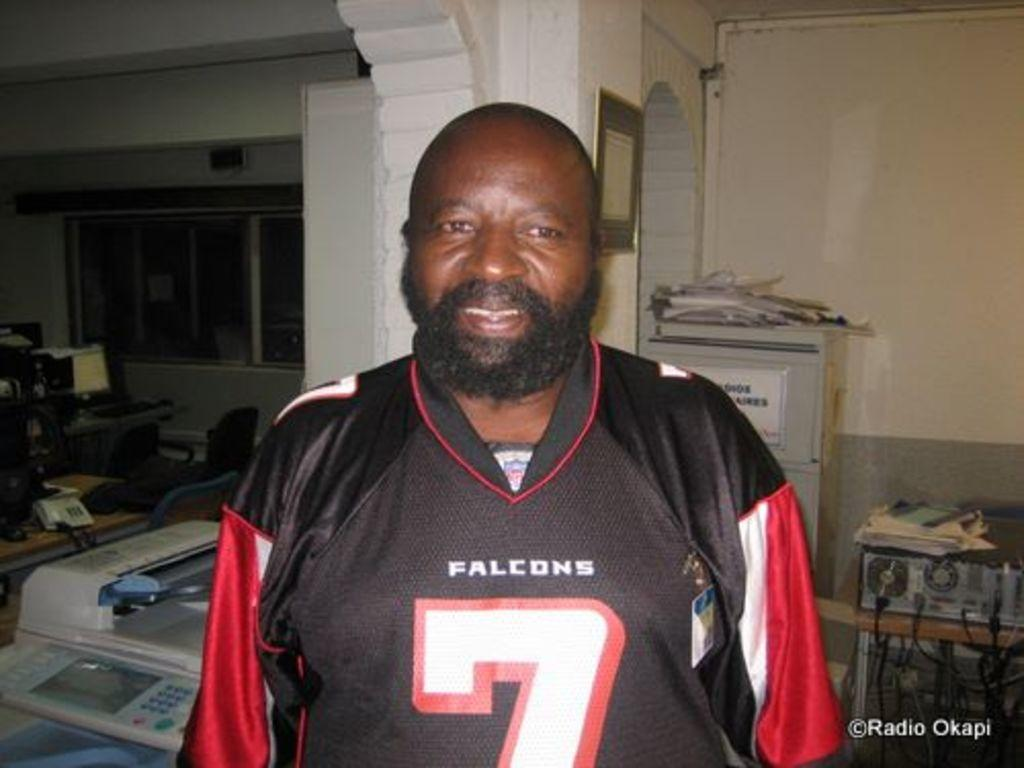Provide a one-sentence caption for the provided image. A man in a jersey with the digit 7 on the front. 